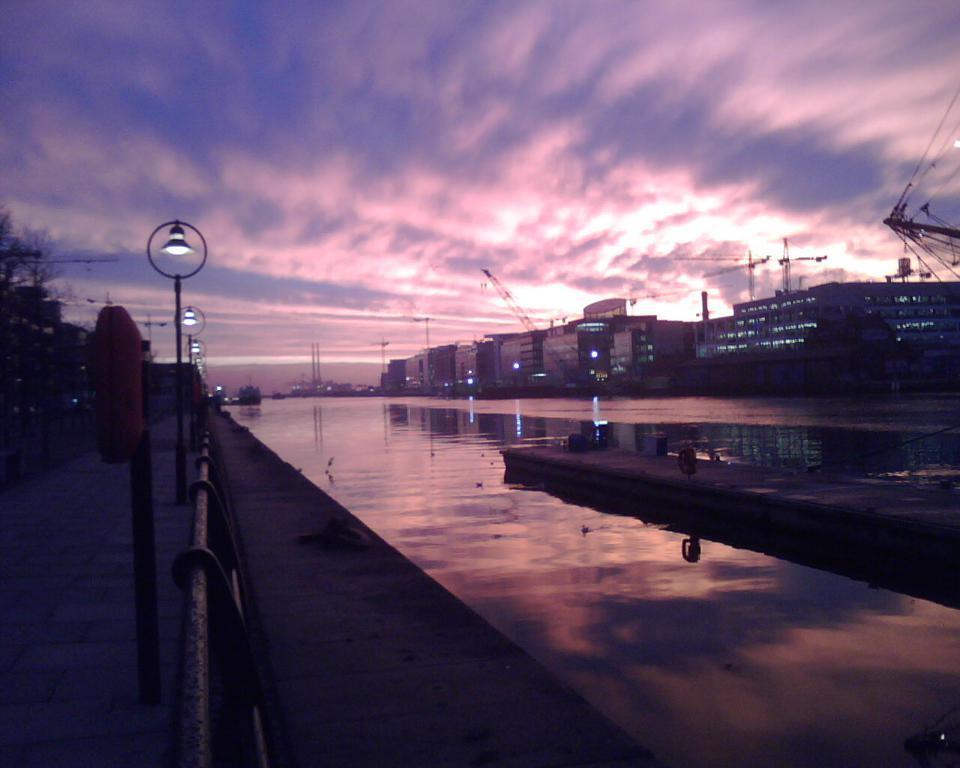Could you give a brief overview of what you see in this image? In this picture,i see few buildings and few cranes and water and few pole lights and trees and a cloudy sky. 